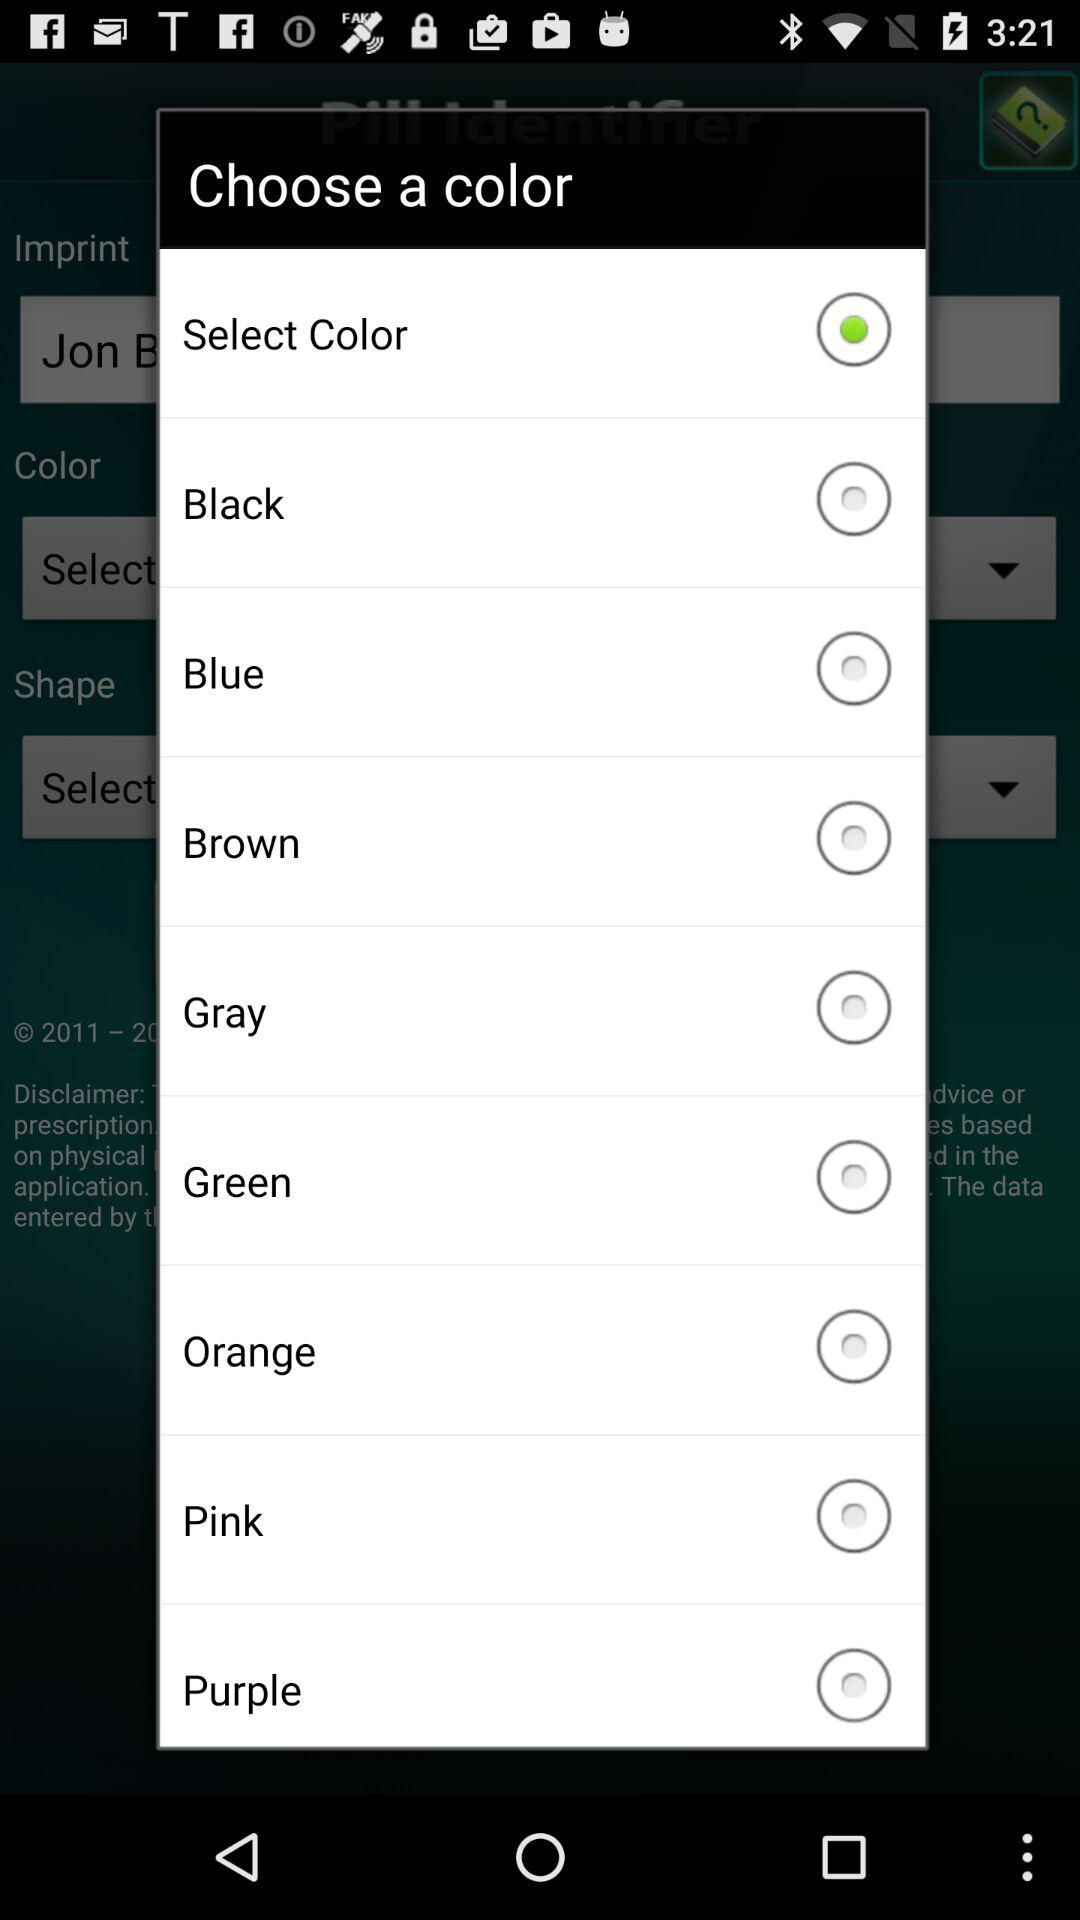Which option has been selected in color?
When the provided information is insufficient, respond with <no answer>. <no answer> 